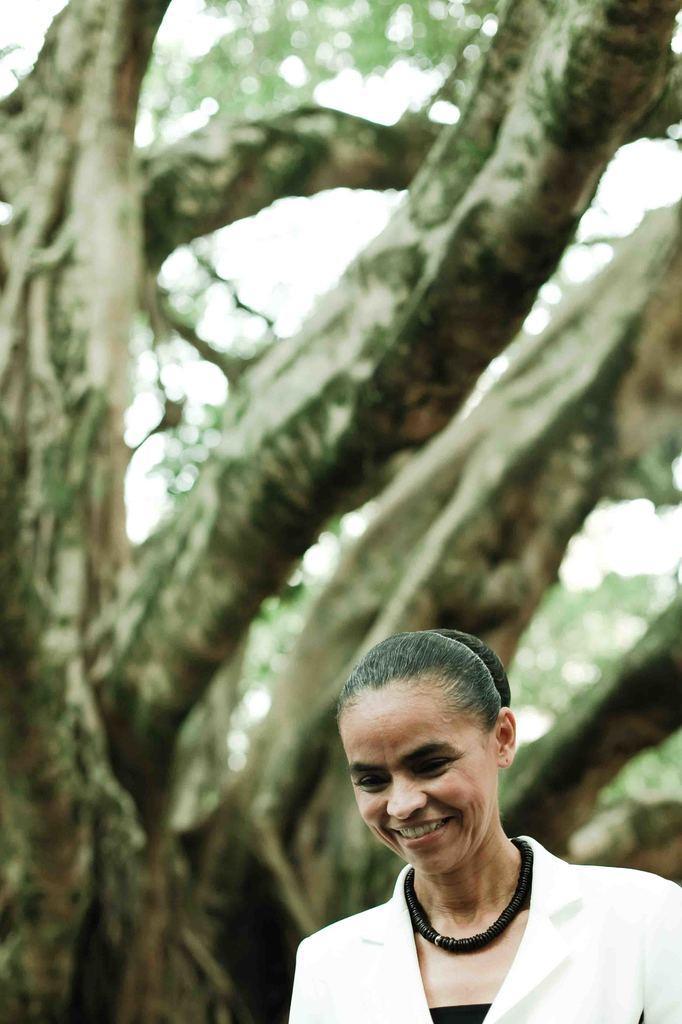Could you give a brief overview of what you see in this image? In the picture there is a woman, behind the woman there is a tree. 